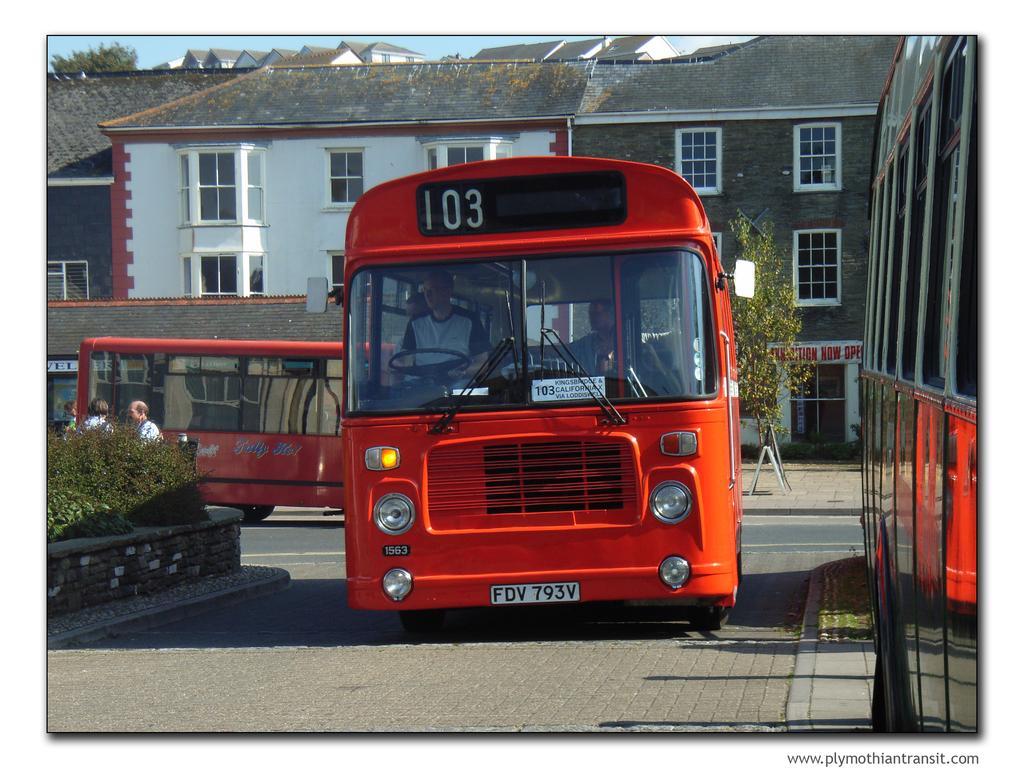Describe this image in one or two sentences. This image is clicked on the road. There are buses moving on the road. Behind the buses there are buildings. In front of the buildings there are plants on the walkway. To the left there are hedges beside the road. At the top there is the sky. 